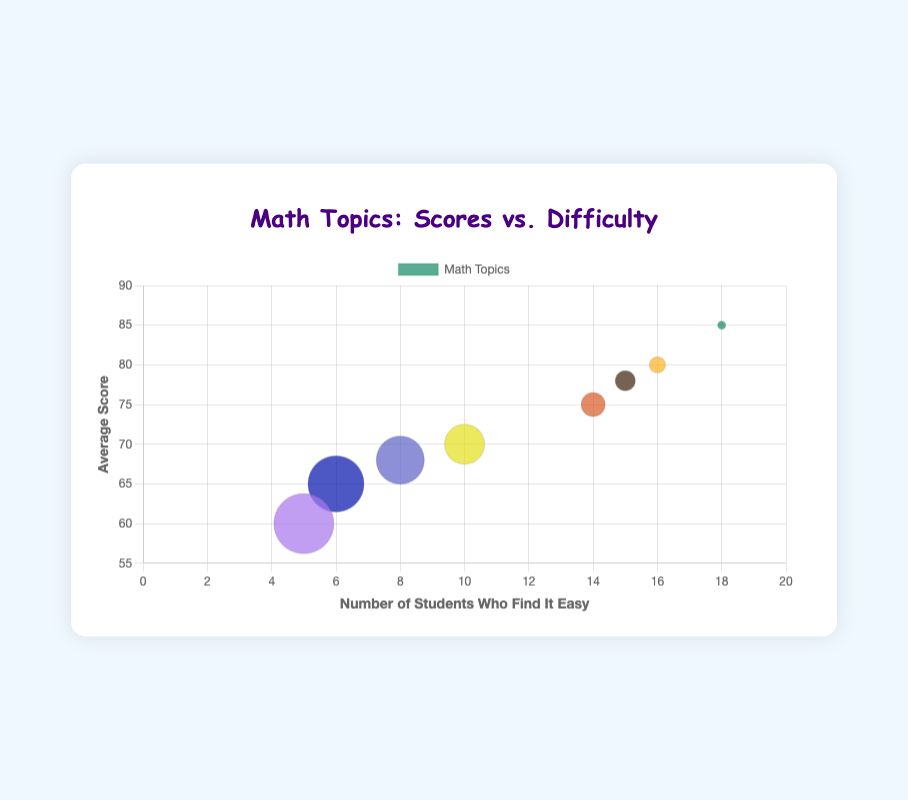What is the title of the chart? The title of the chart is displayed prominently at the top.
Answer: Math Topics: Scores vs. Difficulty Which math topic has the highest average score? The y-axis represents the average score, and the highest point is for Addition with a score of 85.
Answer: Addition How many students find Decimals easy? The x-axis represents the number of students who find a topic easy. For Decimals, the bubble is positioned at 8 on this axis.
Answer: 8 Which topic has the same number of students finding it easy and difficult? The red bubble for Division is positioned at the same point along both the x-axis and the radius, indicating 10 students each for both metrics.
Answer: Division Which math topic has the largest bubble? The size of the bubble represents the number of students who find the topic difficult, so the largest bubble corresponds to Algebra, where 15 students find it difficult.
Answer: Algebra List the topics from highest to lowest average score. Identify and sort the y-coordinates of the bubbles: Addition (85), Subtraction (80), Geometry (78), Multiplication (75), Division (70), Decimals (68), Fractions (65), Algebra (60).
Answer: Addition, Subtraction, Geometry, Multiplication, Division, Decimals, Fractions, Algebra Compare the average scores of Geometry and Multiplication. Which is higher? Geometry has a y-axis value of 78, while Multiplication has 75, making Geometry's score higher.
Answer: Geometry How many easy-finding students are there in total for Fractions and Algebra combined? Sum the x-values for Fractions (6) and Algebra (5): 6 + 5 = 11.
Answer: 11 Is there a topic where more students find it difficult than find it easy? If yes, name them. Check if the radius of the bubble is greater than the x-value position: Division (10 easy, 10 difficult), Fractions (6 easy, 14 difficult), Decimals (8 easy, 12 difficult), Algebra (5 easy, 15 difficult).
Answer: Fractions, Decimals, Algebra Which topic has the smallest bubble, and what does that represent? The smallest bubble has the smallest radius, representing Addition with 2 students finding it difficult.
Answer: Addition 